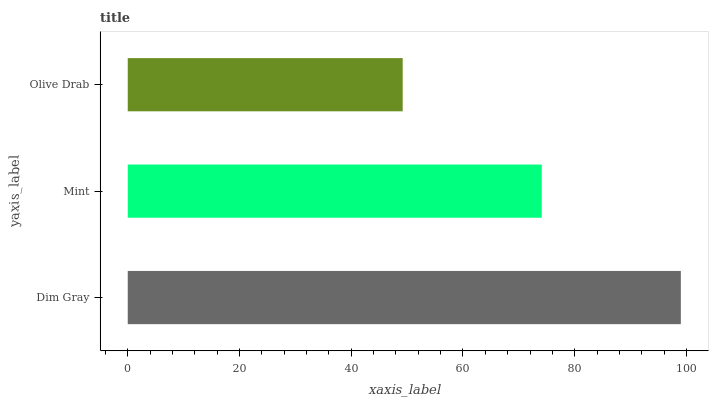Is Olive Drab the minimum?
Answer yes or no. Yes. Is Dim Gray the maximum?
Answer yes or no. Yes. Is Mint the minimum?
Answer yes or no. No. Is Mint the maximum?
Answer yes or no. No. Is Dim Gray greater than Mint?
Answer yes or no. Yes. Is Mint less than Dim Gray?
Answer yes or no. Yes. Is Mint greater than Dim Gray?
Answer yes or no. No. Is Dim Gray less than Mint?
Answer yes or no. No. Is Mint the high median?
Answer yes or no. Yes. Is Mint the low median?
Answer yes or no. Yes. Is Dim Gray the high median?
Answer yes or no. No. Is Dim Gray the low median?
Answer yes or no. No. 